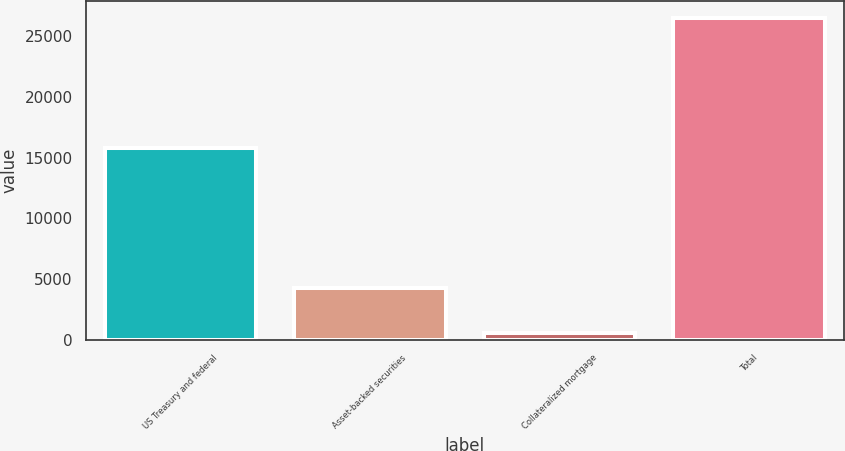<chart> <loc_0><loc_0><loc_500><loc_500><bar_chart><fcel>US Treasury and federal<fcel>Asset-backed securities<fcel>Collateralized mortgage<fcel>Total<nl><fcel>15760<fcel>4276<fcel>548<fcel>26528<nl></chart> 